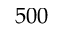Convert formula to latex. <formula><loc_0><loc_0><loc_500><loc_500>5 0 0</formula> 